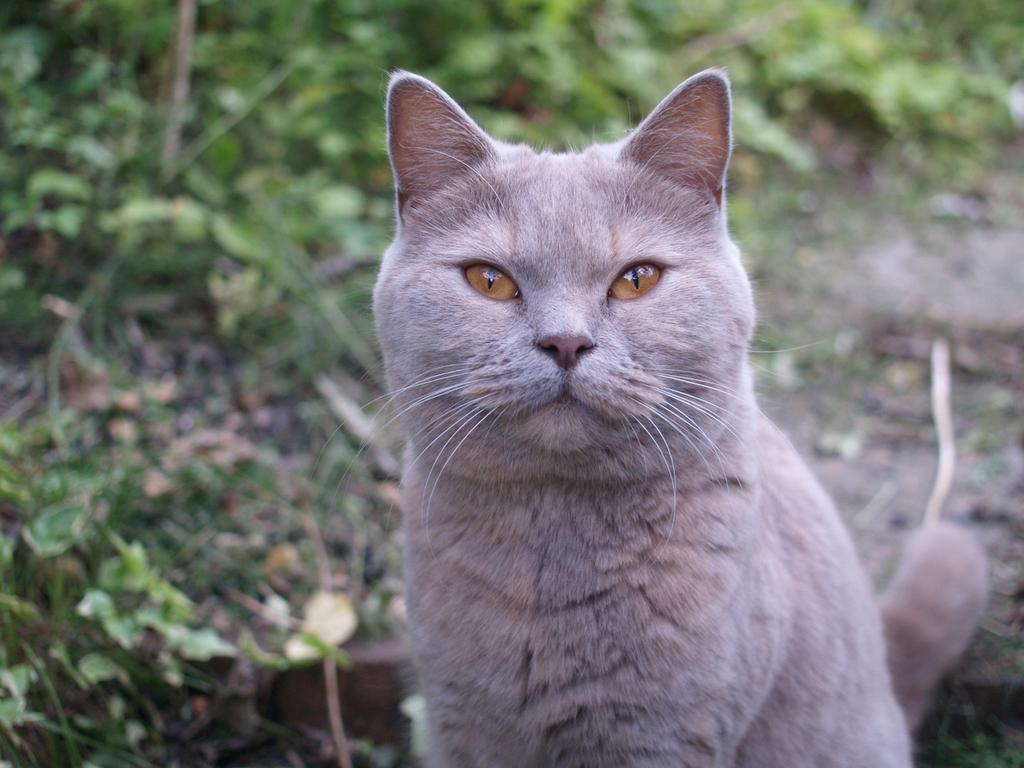What is the main subject of the image? There is a cat in the center of the image. What can be seen in the background of the image? There are trees in the background of the image. How many trucks can be seen in the image? There are no trucks present in the image. Can you see the cat's veins in the image? The image does not show the cat's veins; it only shows the cat's fur and body. 